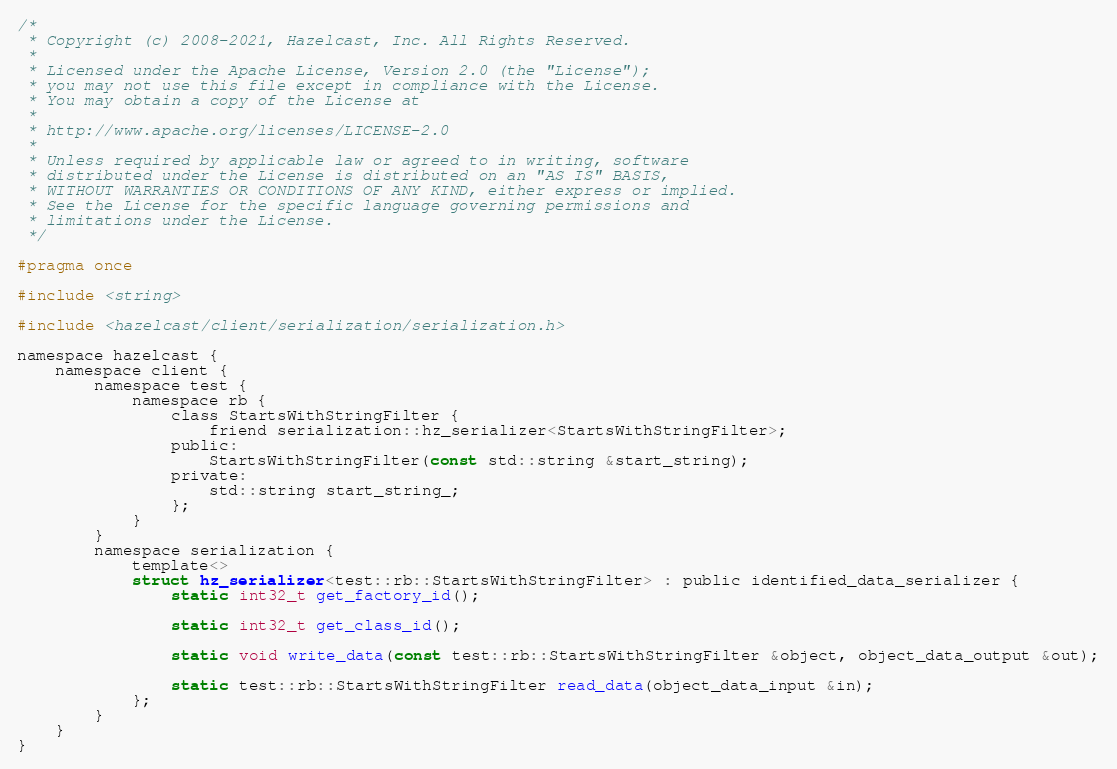Convert code to text. <code><loc_0><loc_0><loc_500><loc_500><_C_>/*
 * Copyright (c) 2008-2021, Hazelcast, Inc. All Rights Reserved.
 *
 * Licensed under the Apache License, Version 2.0 (the "License");
 * you may not use this file except in compliance with the License.
 * You may obtain a copy of the License at
 *
 * http://www.apache.org/licenses/LICENSE-2.0
 *
 * Unless required by applicable law or agreed to in writing, software
 * distributed under the License is distributed on an "AS IS" BASIS,
 * WITHOUT WARRANTIES OR CONDITIONS OF ANY KIND, either express or implied.
 * See the License for the specific language governing permissions and
 * limitations under the License.
 */

#pragma once

#include <string>

#include <hazelcast/client/serialization/serialization.h>

namespace hazelcast {
    namespace client {
        namespace test {
            namespace rb {
                class StartsWithStringFilter {
                    friend serialization::hz_serializer<StartsWithStringFilter>;
                public:
                    StartsWithStringFilter(const std::string &start_string);
                private:
                    std::string start_string_;
                };
            }
        }
        namespace serialization {
            template<>
            struct hz_serializer<test::rb::StartsWithStringFilter> : public identified_data_serializer {
                static int32_t get_factory_id();

                static int32_t get_class_id();

                static void write_data(const test::rb::StartsWithStringFilter &object, object_data_output &out);

                static test::rb::StartsWithStringFilter read_data(object_data_input &in);
            };
        }
    }
}


</code> 